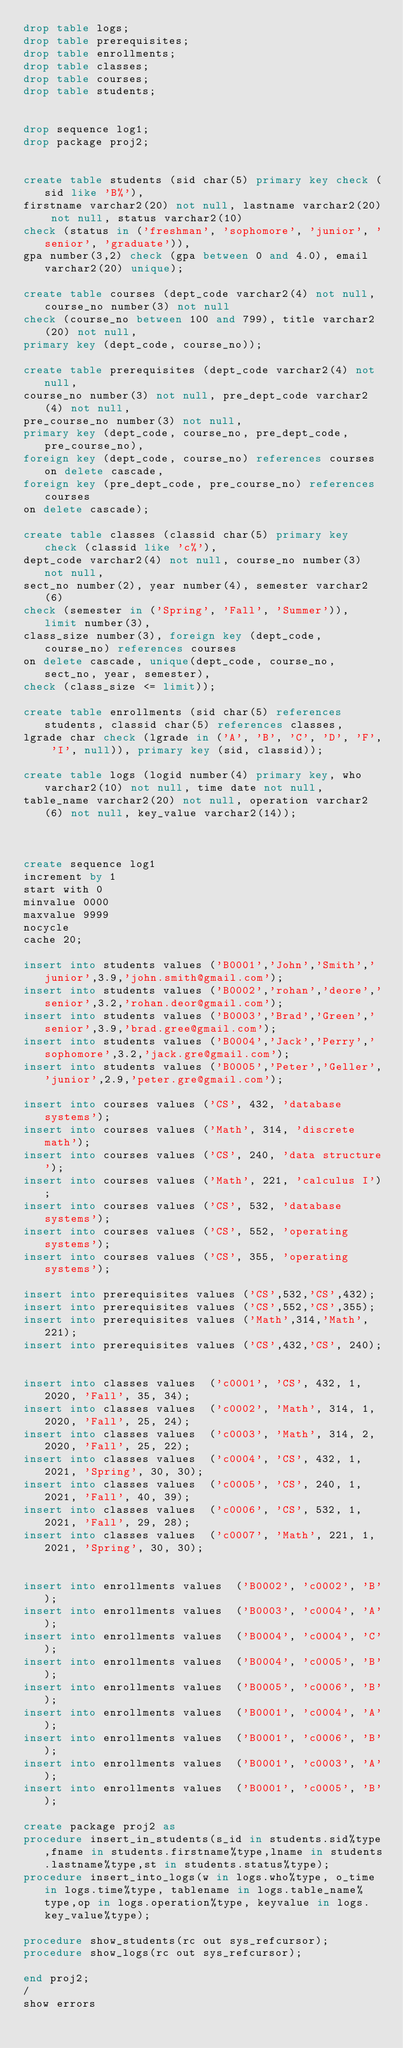Convert code to text. <code><loc_0><loc_0><loc_500><loc_500><_SQL_>drop table logs;
drop table prerequisites;
drop table enrollments;
drop table classes;
drop table courses;
drop table students;


drop sequence log1;
drop package proj2;


create table students (sid char(5) primary key check (sid like 'B%'),
firstname varchar2(20) not null, lastname varchar2(20) not null, status varchar2(10) 
check (status in ('freshman', 'sophomore', 'junior', 'senior', 'graduate')), 
gpa number(3,2) check (gpa between 0 and 4.0), email varchar2(20) unique);

create table courses (dept_code varchar2(4) not null, course_no number(3) not null
check (course_no between 100 and 799), title varchar2(20) not null,
primary key (dept_code, course_no));

create table prerequisites (dept_code varchar2(4) not null,
course_no number(3) not null, pre_dept_code varchar2(4) not null,
pre_course_no number(3) not null,
primary key (dept_code, course_no, pre_dept_code, pre_course_no),
foreign key (dept_code, course_no) references courses on delete cascade,
foreign key (pre_dept_code, pre_course_no) references courses
on delete cascade);

create table classes (classid char(5) primary key check (classid like 'c%'), 
dept_code varchar2(4) not null, course_no number(3) not null, 
sect_no number(2), year number(4), semester varchar2(6) 
check (semester in ('Spring', 'Fall', 'Summer')), limit number(3), 
class_size number(3), foreign key (dept_code, course_no) references courses
on delete cascade, unique(dept_code, course_no, sect_no, year, semester),
check (class_size <= limit));

create table enrollments (sid char(5) references students, classid char(5) references classes, 
lgrade char check (lgrade in ('A', 'B', 'C', 'D', 'F', 'I', null)), primary key (sid, classid));

create table logs (logid number(4) primary key, who varchar2(10) not null, time date not null,
table_name varchar2(20) not null, operation varchar2(6) not null, key_value varchar2(14));



create sequence log1
increment by 1
start with 0
minvalue 0000
maxvalue 9999
nocycle
cache 20;

insert into students values ('B0001','John','Smith','junior',3.9,'john.smith@gmail.com');
insert into students values ('B0002','rohan','deore','senior',3.2,'rohan.deor@gmail.com');
insert into students values ('B0003','Brad','Green','senior',3.9,'brad.gree@gmail.com');
insert into students values ('B0004','Jack','Perry','sophomore',3.2,'jack.gre@gmail.com');
insert into students values ('B0005','Peter','Geller','junior',2.9,'peter.gre@gmail.com');

insert into courses values ('CS', 432, 'database systems');
insert into courses values ('Math', 314, 'discrete math');
insert into courses values ('CS', 240, 'data structure');
insert into courses values ('Math', 221, 'calculus I');
insert into courses values ('CS', 532, 'database systems');
insert into courses values ('CS', 552, 'operating systems');
insert into courses values ('CS', 355, 'operating systems');

insert into prerequisites values ('CS',532,'CS',432);
insert into prerequisites values ('CS',552,'CS',355);
insert into prerequisites values ('Math',314,'Math', 221);
insert into prerequisites values ('CS',432,'CS', 240);


insert into classes values  ('c0001', 'CS', 432, 1, 2020, 'Fall', 35, 34);
insert into classes values  ('c0002', 'Math', 314, 1, 2020, 'Fall', 25, 24);
insert into classes values  ('c0003', 'Math', 314, 2, 2020, 'Fall', 25, 22);
insert into classes values  ('c0004', 'CS', 432, 1, 2021, 'Spring', 30, 30);
insert into classes values  ('c0005', 'CS', 240, 1, 2021, 'Fall', 40, 39);
insert into classes values  ('c0006', 'CS', 532, 1, 2021, 'Fall', 29, 28);
insert into classes values  ('c0007', 'Math', 221, 1, 2021, 'Spring', 30, 30);


insert into enrollments values  ('B0002', 'c0002', 'B');
insert into enrollments values  ('B0003', 'c0004', 'A');
insert into enrollments values  ('B0004', 'c0004', 'C');
insert into enrollments values  ('B0004', 'c0005', 'B');
insert into enrollments values  ('B0005', 'c0006', 'B');
insert into enrollments values  ('B0001', 'c0004', 'A');
insert into enrollments values  ('B0001', 'c0006', 'B');
insert into enrollments values  ('B0001', 'c0003', 'A');
insert into enrollments values  ('B0001', 'c0005', 'B');

create package proj2 as 
procedure insert_in_students(s_id in students.sid%type,fname in students.firstname%type,lname in students.lastname%type,st in students.status%type);
procedure insert_into_logs(w in logs.who%type, o_time in logs.time%type, tablename in logs.table_name%type,op in logs.operation%type, keyvalue in logs.key_value%type);

procedure show_students(rc out sys_refcursor);
procedure show_logs(rc out sys_refcursor);

end proj2;
/
show errors
</code> 